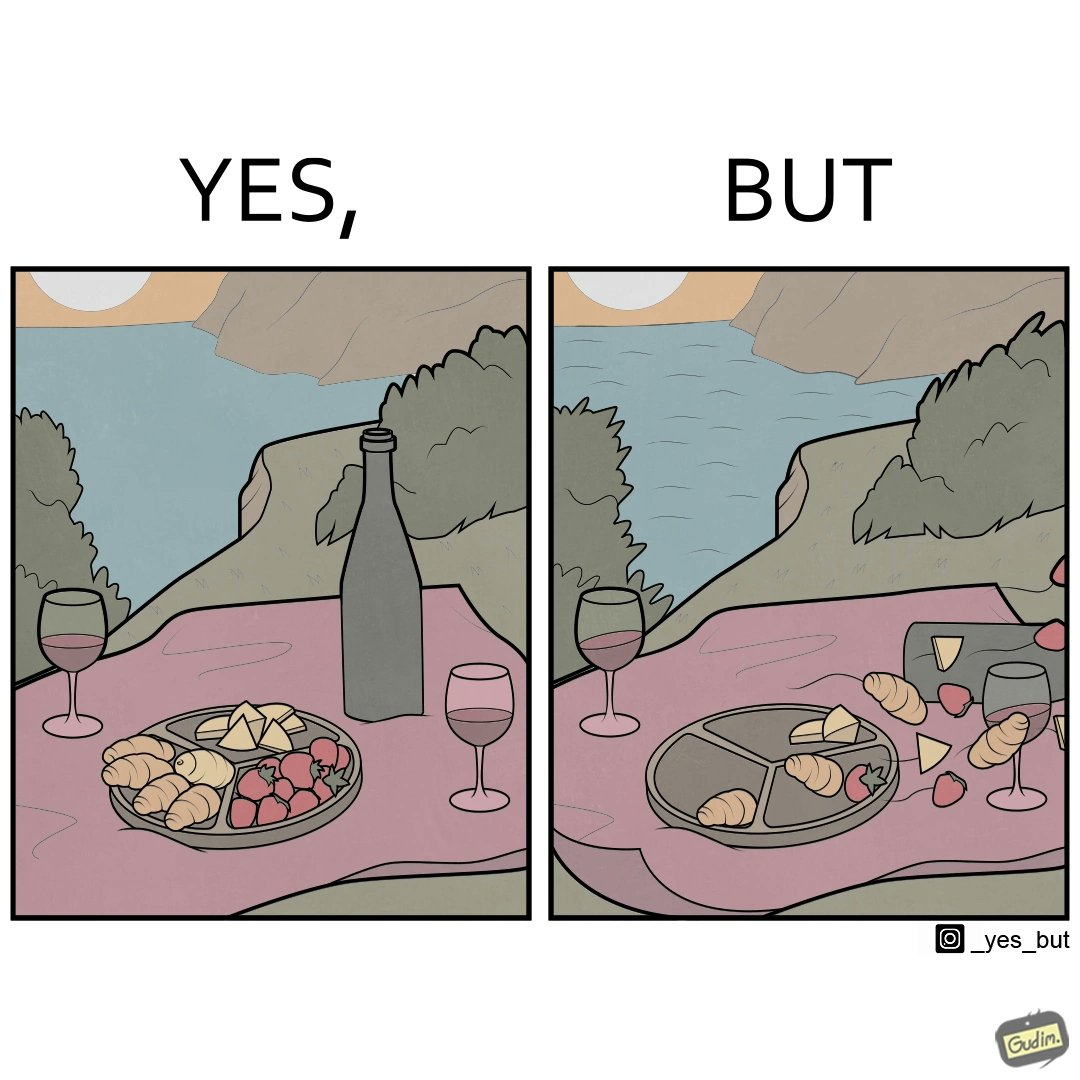Does this image contain satire or humor? Yes, this image is satirical. 